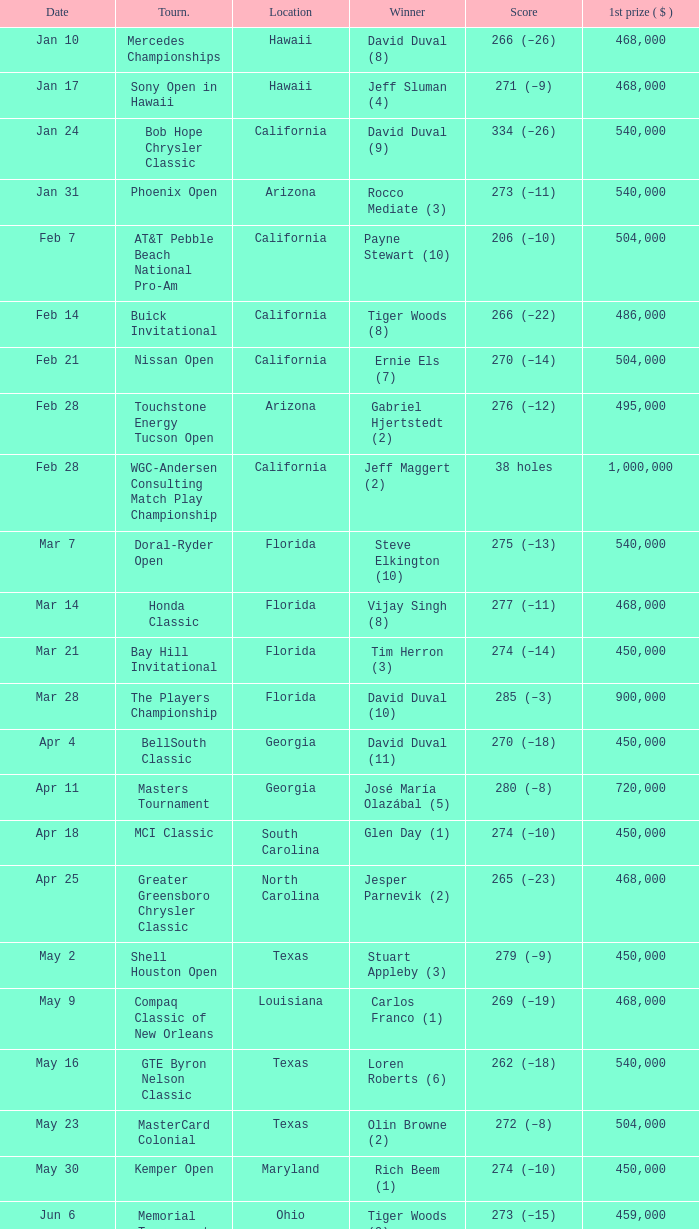Who is the winner of the tournament in Georgia on Oct 3? David Toms (3). Would you mind parsing the complete table? {'header': ['Date', 'Tourn.', 'Location', 'Winner', 'Score', '1st prize ( $ )'], 'rows': [['Jan 10', 'Mercedes Championships', 'Hawaii', 'David Duval (8)', '266 (–26)', '468,000'], ['Jan 17', 'Sony Open in Hawaii', 'Hawaii', 'Jeff Sluman (4)', '271 (–9)', '468,000'], ['Jan 24', 'Bob Hope Chrysler Classic', 'California', 'David Duval (9)', '334 (–26)', '540,000'], ['Jan 31', 'Phoenix Open', 'Arizona', 'Rocco Mediate (3)', '273 (–11)', '540,000'], ['Feb 7', 'AT&T Pebble Beach National Pro-Am', 'California', 'Payne Stewart (10)', '206 (–10)', '504,000'], ['Feb 14', 'Buick Invitational', 'California', 'Tiger Woods (8)', '266 (–22)', '486,000'], ['Feb 21', 'Nissan Open', 'California', 'Ernie Els (7)', '270 (–14)', '504,000'], ['Feb 28', 'Touchstone Energy Tucson Open', 'Arizona', 'Gabriel Hjertstedt (2)', '276 (–12)', '495,000'], ['Feb 28', 'WGC-Andersen Consulting Match Play Championship', 'California', 'Jeff Maggert (2)', '38 holes', '1,000,000'], ['Mar 7', 'Doral-Ryder Open', 'Florida', 'Steve Elkington (10)', '275 (–13)', '540,000'], ['Mar 14', 'Honda Classic', 'Florida', 'Vijay Singh (8)', '277 (–11)', '468,000'], ['Mar 21', 'Bay Hill Invitational', 'Florida', 'Tim Herron (3)', '274 (–14)', '450,000'], ['Mar 28', 'The Players Championship', 'Florida', 'David Duval (10)', '285 (–3)', '900,000'], ['Apr 4', 'BellSouth Classic', 'Georgia', 'David Duval (11)', '270 (–18)', '450,000'], ['Apr 11', 'Masters Tournament', 'Georgia', 'José María Olazábal (5)', '280 (–8)', '720,000'], ['Apr 18', 'MCI Classic', 'South Carolina', 'Glen Day (1)', '274 (–10)', '450,000'], ['Apr 25', 'Greater Greensboro Chrysler Classic', 'North Carolina', 'Jesper Parnevik (2)', '265 (–23)', '468,000'], ['May 2', 'Shell Houston Open', 'Texas', 'Stuart Appleby (3)', '279 (–9)', '450,000'], ['May 9', 'Compaq Classic of New Orleans', 'Louisiana', 'Carlos Franco (1)', '269 (–19)', '468,000'], ['May 16', 'GTE Byron Nelson Classic', 'Texas', 'Loren Roberts (6)', '262 (–18)', '540,000'], ['May 23', 'MasterCard Colonial', 'Texas', 'Olin Browne (2)', '272 (–8)', '504,000'], ['May 30', 'Kemper Open', 'Maryland', 'Rich Beem (1)', '274 (–10)', '450,000'], ['Jun 6', 'Memorial Tournament', 'Ohio', 'Tiger Woods (9)', '273 (–15)', '459,000'], ['Jun 14', 'FedEx St. Jude Classic', 'Tennessee', 'Ted Tryba (2)', '265 (–19)', '450,000'], ['Jun 20', 'U.S. Open', 'North Carolina', 'Payne Stewart (11)', '279 (–1)', '625,000'], ['Jun 27', 'Buick Classic', 'New York', 'Duffy Waldorf (2)', '276 (–8)', '450,000'], ['Jul 4', 'Motorola Western Open', 'Illinois', 'Tiger Woods (10)', '273 (–15)', '450,000'], ['Jul 11', 'Greater Milwaukee Open', 'Wisconsin', 'Carlos Franco (2)', '264 (–20)', '414,000'], ['Jul 18', 'British Open', 'Scotland', 'Paul Lawrie (1)', '290 (+6)', '546,805'], ['Jul 25', 'John Deere Classic', 'Illinois', 'J. L. Lewis (1)', '261 (–19)', '360,000'], ['Aug 1', 'Canon Greater Hartford Open', 'Connecticut', 'Brent Geiberger (1)', '262 (–18)', '450,000'], ['Aug 8', 'Buick Open', 'Michigan', 'Tom Pernice, Jr. (1)', '270 (–18)', '432,000'], ['Aug 15', 'PGA Championship', 'Illinois', 'Tiger Woods (11)', '277 (–11)', '630,000'], ['Aug 22', 'Sprint International', 'Colorado', 'David Toms (2)', '47 ( Stableford )', '468,000'], ['Aug 29', 'Reno-Tahoe Open', 'Nevada', 'Notah Begay III (1)', '274 (–14)', '495,000'], ['Aug 29', 'WGC-NEC Invitational', 'Ohio', 'Tiger Woods (12)', '270 (–10)', '1,000,000'], ['Sep 5', 'Air Canada Championship', 'Canada', 'Mike Weir (1)', '266 (–18)', '450,000'], ['Sep 12', 'Bell Canadian Open', 'Canada', 'Hal Sutton (11)', '275 (–13)', '450,000'], ['Sep 19', 'B.C. Open', 'New York', 'Brad Faxon (5)', '273 (–15)', '288,000'], ['Sep 26', 'Westin Texas Open', 'Texas', 'Duffy Waldorf (3)', '270 (–18)', '360,000'], ['Oct 3', 'Buick Challenge', 'Georgia', 'David Toms (3)', '271 (–17)', '324,000'], ['Oct 10', 'Michelob Championship at Kingsmill', 'Virginia', 'Notah Begay III (2)', '274 (–10)', '450,000'], ['Oct 17', 'Las Vegas Invitational', 'Nevada', 'Jim Furyk (4)', '331 (–29)', '450,000'], ['Oct 24', 'National Car Rental Golf Classic Disney', 'Florida', 'Tiger Woods (13)', '271 (–17)', '450,000'], ['Oct 31', 'The Tour Championship', 'Texas', 'Tiger Woods (14)', '269 (–15)', '900,000'], ['Nov 1', 'Southern Farm Bureau Classic', 'Mississippi', 'Brian Henninger (2)', '202 (–14)', '360,000'], ['Nov 7', 'WGC-American Express Championship', 'Spain', 'Tiger Woods (15)', '278 (–6)', '1,000,000']]} 